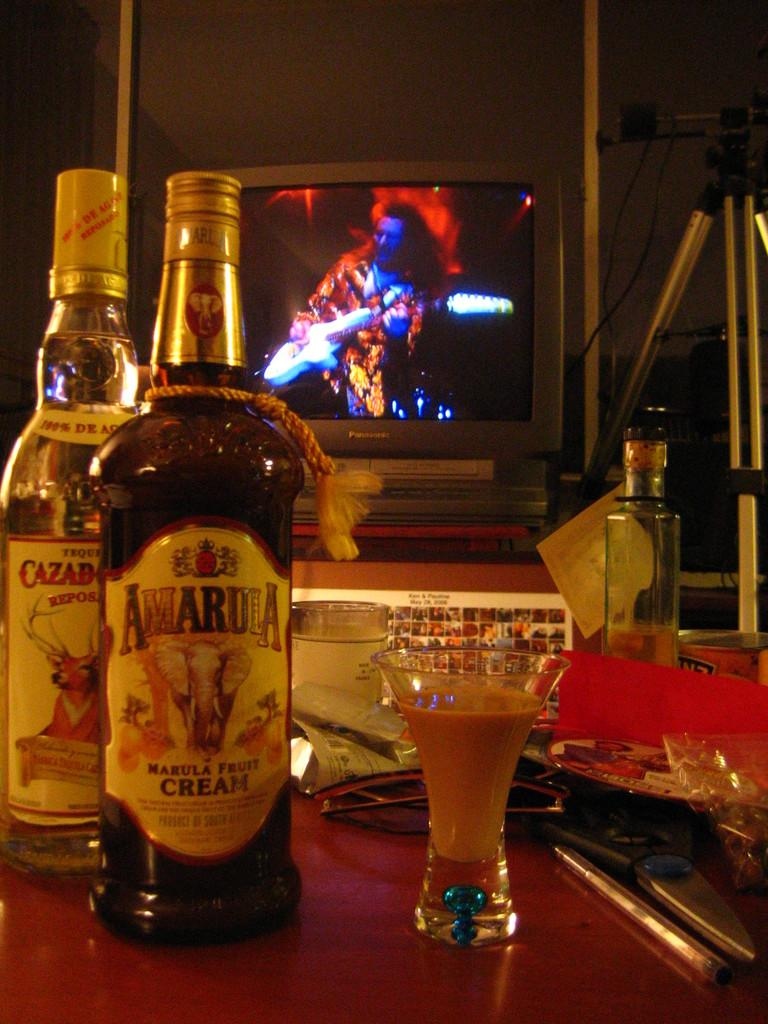<image>
Present a compact description of the photo's key features. A bottle of cream liquour and a bottle of tequila sit next to each other on a bar. 